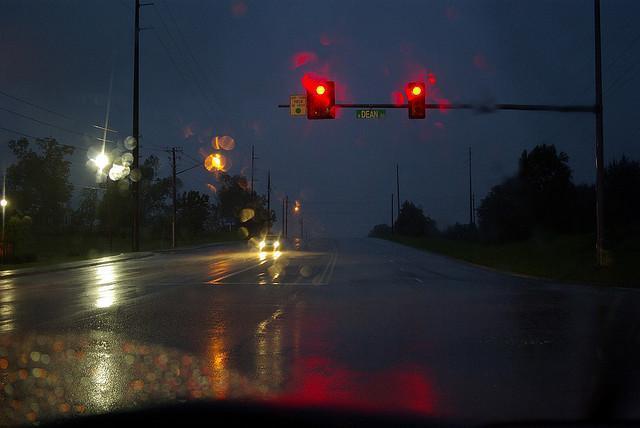How many horses are there?
Give a very brief answer. 0. 